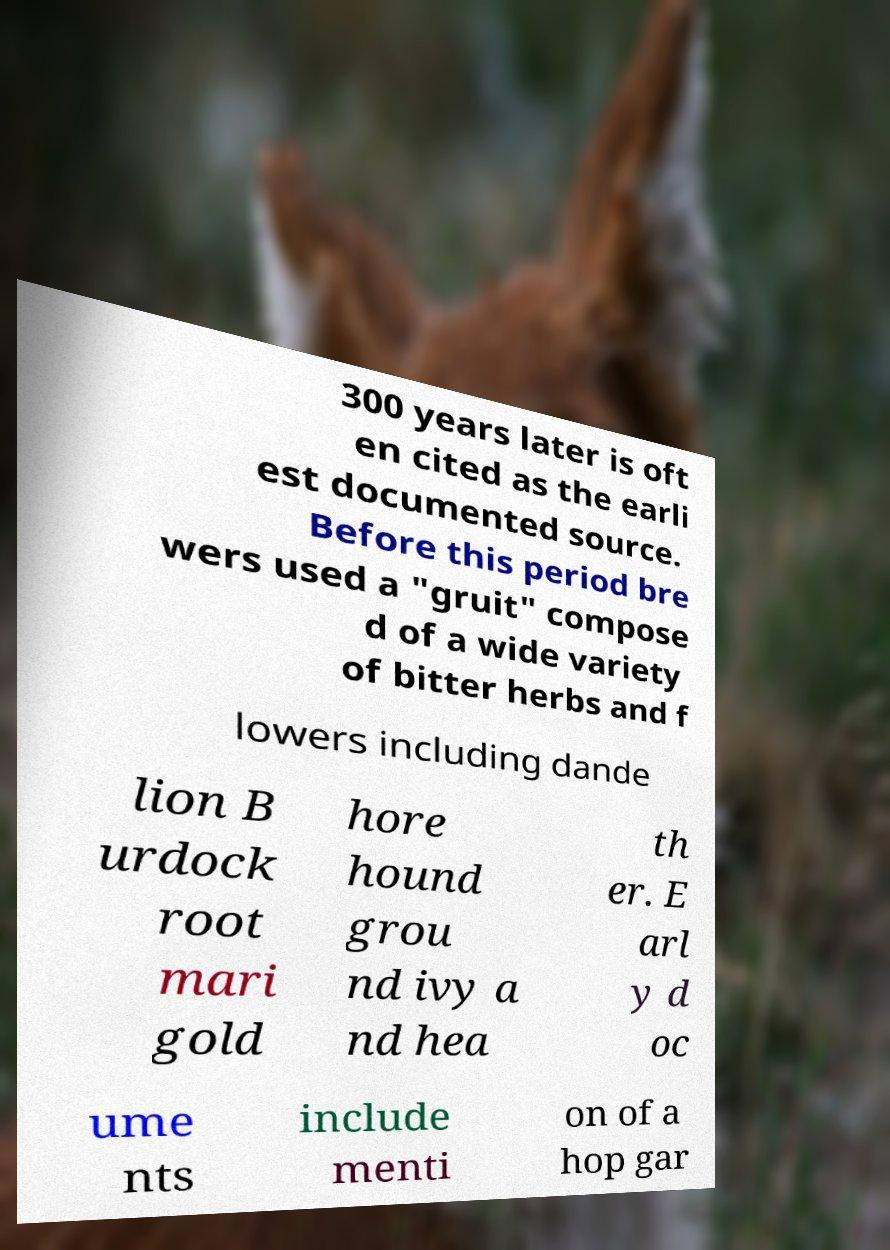Please read and relay the text visible in this image. What does it say? 300 years later is oft en cited as the earli est documented source. Before this period bre wers used a "gruit" compose d of a wide variety of bitter herbs and f lowers including dande lion B urdock root mari gold hore hound grou nd ivy a nd hea th er. E arl y d oc ume nts include menti on of a hop gar 